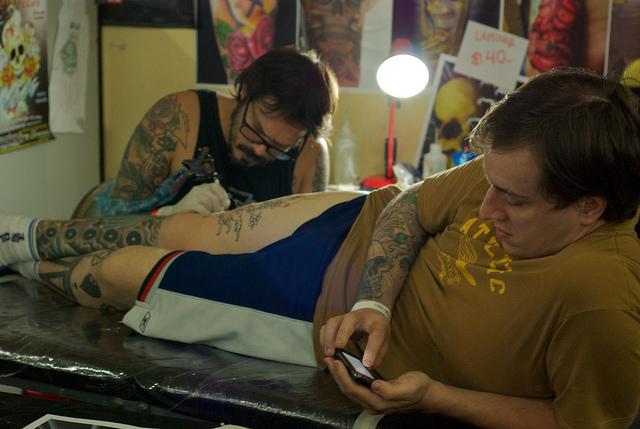Is the man on the table in discomfort?
Be succinct. No. What is displayed behind the dollar sign on the sign behind the man?
Concise answer only. 40. Does this picture involve cooking?
Concise answer only. No. What is happening to the man's leg?
Answer briefly. Tattoo. 